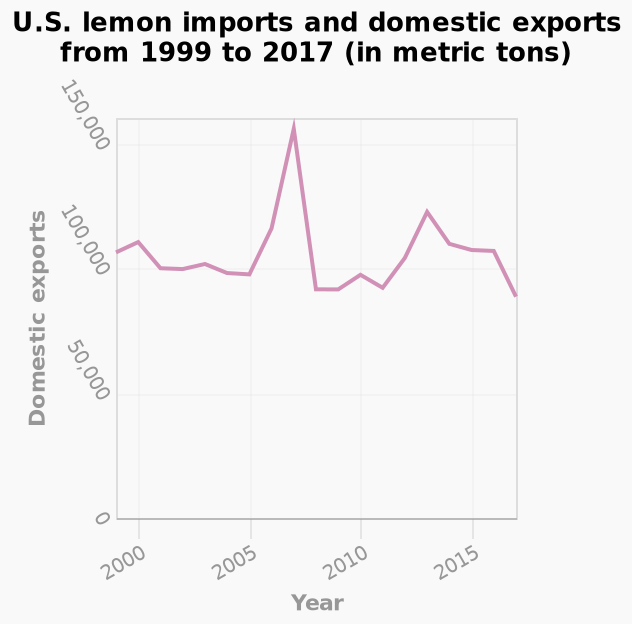<image>
Are there any significant fluctuations in the data? Yes, there are noticeable ups and downs in the trend. Can you describe the overall pattern in the data? The data exhibits a mixed trend with both rises and falls. 